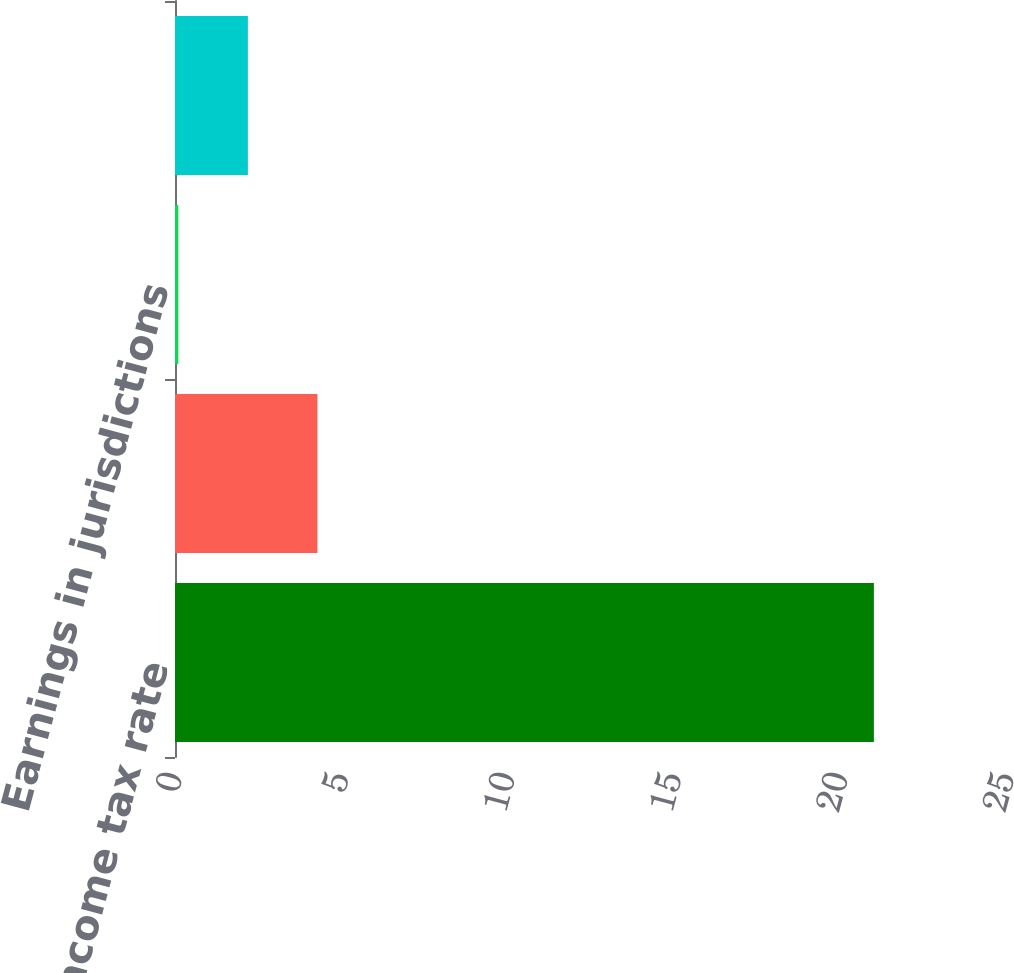Convert chart to OTSL. <chart><loc_0><loc_0><loc_500><loc_500><bar_chart><fcel>Federal income tax rate<fcel>State taxes net of federal<fcel>Earnings in jurisdictions<fcel>Other including tax reserves<nl><fcel>21<fcel>4.28<fcel>0.1<fcel>2.19<nl></chart> 